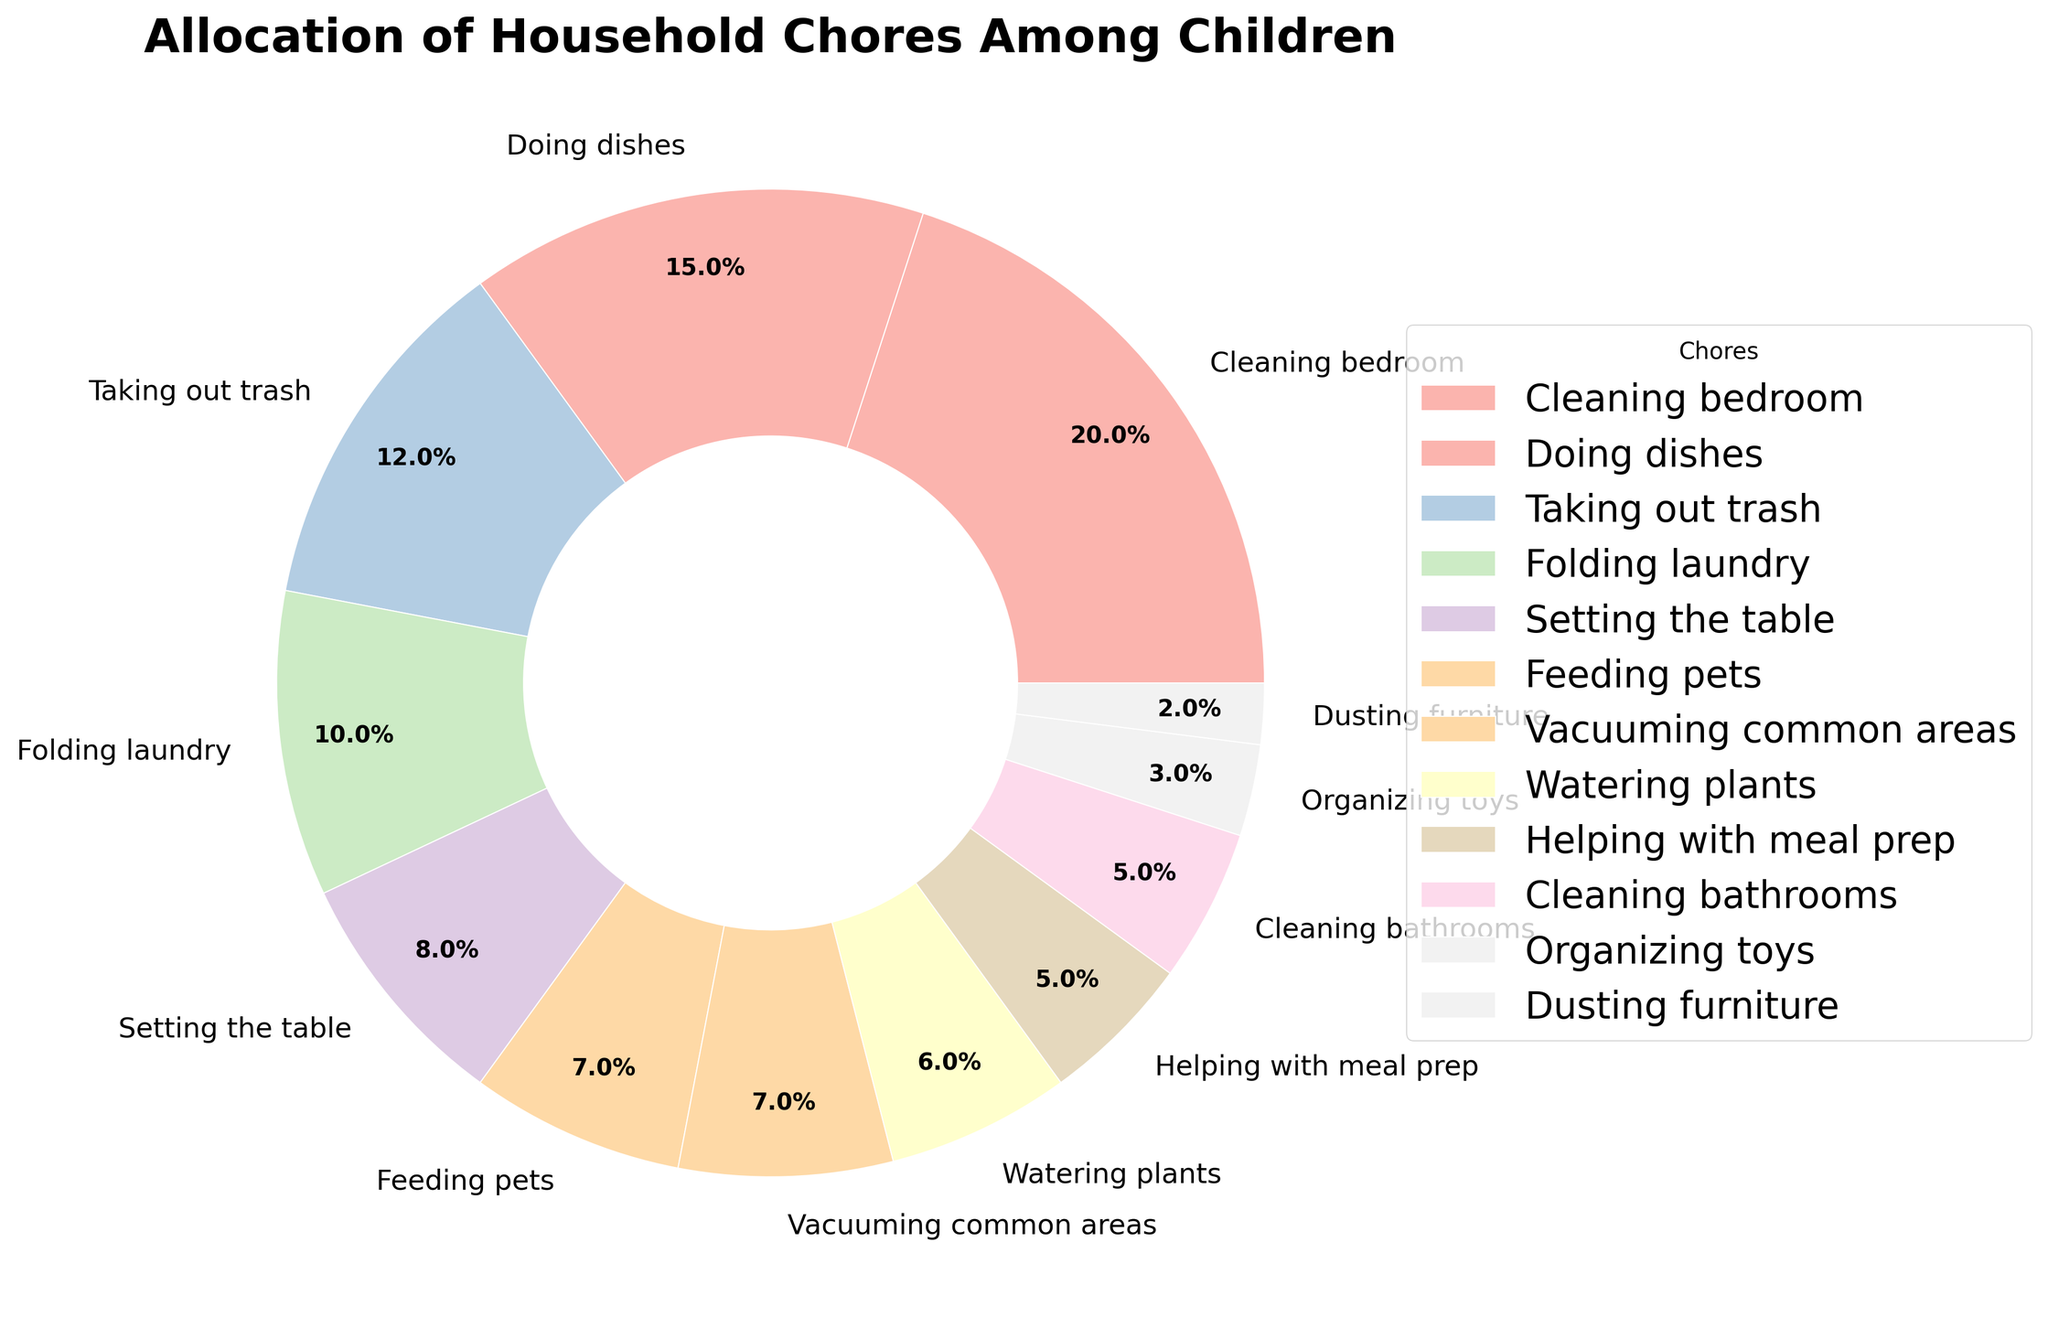Which chore has the highest allocation percentage? Look at the percentages associated with each chore and identify the highest value. The chore with the highest allocation percentage is "Cleaning bedroom" at 20%.
Answer: Cleaning bedroom What is the total allocation percentage for "Cleaning bathrooms", "Organizing toys", and "Dusting furniture"? Sum the percentages of "Cleaning bathrooms" (5%), "Organizing toys" (3%), and "Dusting furniture" (2%). The total is 5% + 3% + 2% = 10%.
Answer: 10% Which chore is allocated more, "Feeding pets" or "Vacuuming common areas"? Compare the percentage allocated to "Feeding pets" (7%) with that of "Vacuuming common areas" (7%). Both chores have the same allocation.
Answer: Equal How does the percentage allocated to "Doing dishes" compare to that of "Setting the table"? Compare the percentage allocated to "Doing dishes" (15%) with that of "Setting the table" (8%). "Doing dishes" has a higher allocation.
Answer: Doing dishes Is the combined percentage of "Watering plants" and "Helping with meal prep" greater than that of "Taking out trash"? The sum of "Watering plants" (6%) and "Helping with meal prep" (5%) is 6% + 5% = 11%. Compare this to the "Taking out trash" percentage (12%). 11% is less than 12%.
Answer: No What chores together are allocated more than "Cleaning bedroom"? Identify chores whose combined percentages exceed "Cleaning bedroom" (20%). The chores "Doing dishes" (15%) and "Taking out trash" (12%) together add up to 27%, exceeding 20%.
Answer: "Doing dishes" and "Taking out trash" What is the difference in allocation between "Folding laundry" and "Feeding pets"? Subtract the percentage of "Feeding pets" (7%) from that of "Folding laundry" (10%). The difference is 10% - 7% = 3%.
Answer: 3% Which chores have an allocation percentage that is less than "Vacuuming common areas" but more than "Watering plants"? "Vacuuming common areas" (7%) and "Watering plants" (6%). The chores that fit this criterion are none, as 7% and 6% are consecutive values.
Answer: None What is the percentage allocated to all chores except "Cleaning bedroom"? Sum all chore percentages except "Cleaning bedroom" (20%). The total is 100% - 20% = 80%.
Answer: 80% 